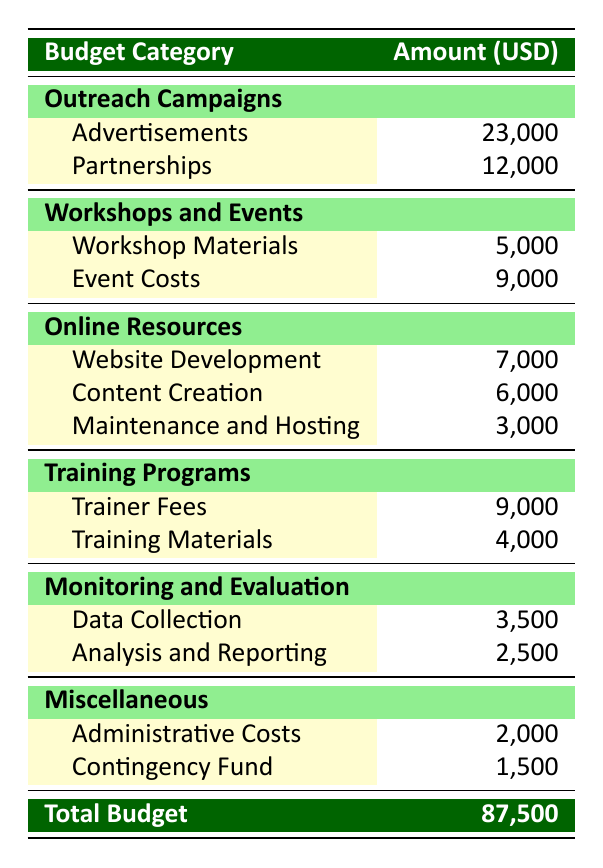What is the total amount allocated for Outreach Campaigns? To find the total for Outreach Campaigns, add the amounts allocated for Advertisements (23,000) and Partnerships (12,000). So, 15,000 + 8,000 + 4,000 = 23,000.
Answer: 35,000 How much was spent on Workshop Materials? The table directly states that the amount allocated for Workshop Materials is 5,000.
Answer: 5,000 Is the amount allocated for Website Development greater than that for Event Costs? The amount for Website Development is 7,000, while Event Costs are 9,000. Since 7,000 is less than 9,000, the answer is no.
Answer: No What is the combined total for Training Programs and Monitoring and Evaluation? To find the combined total, sum the amounts from Training Programs (9,000 + 4,000 = 13,000) and Monitoring and Evaluation (3,500 + 2,500 = 6,000). Adding both totals gives 13,000 + 6,000 = 19,000.
Answer: 19,000 How much of the budget was spent on Educational Kits compared to Contingency Fund? The amount allocated for Educational Kits is 3,000, and for Contingency Fund is 1,500. Comparing these, 3,000 is greater than 1,500. Therefore, more was spent on Educational Kits.
Answer: Yes What percentage of the total budget is allocated for Administrative Costs? The total budget is 87,500, and Administrative Costs are 2,000. To find the percentage, (2,000 / 87,500) * 100 = approximately 2.29%.
Answer: 2.29% How much more is spent on Content Creation than Maintenance and Hosting? The amount for Content Creation is 6,000 and for Maintenance and Hosting is 3,000. The difference is 6,000 - 3,000 = 3,000.
Answer: 3,000 What is the total budget allocation for Workshops and Events? To find the total for Workshops and Events, add the amounts for Workshop Materials (5,000) and Event Costs (9,000). So, 5,000 + 9,000 = 14,000.
Answer: 14,000 Which category has the highest spending in total? Summing the categories: Outreach Campaigns (35,000), Workshops and Events (14,000), Online Resources (16,000), Training Programs (13,000), Monitoring and Evaluation (6,000), and Miscellaneous (3,500). Outreach Campaigns have the highest total of 35,000.
Answer: Outreach Campaigns 